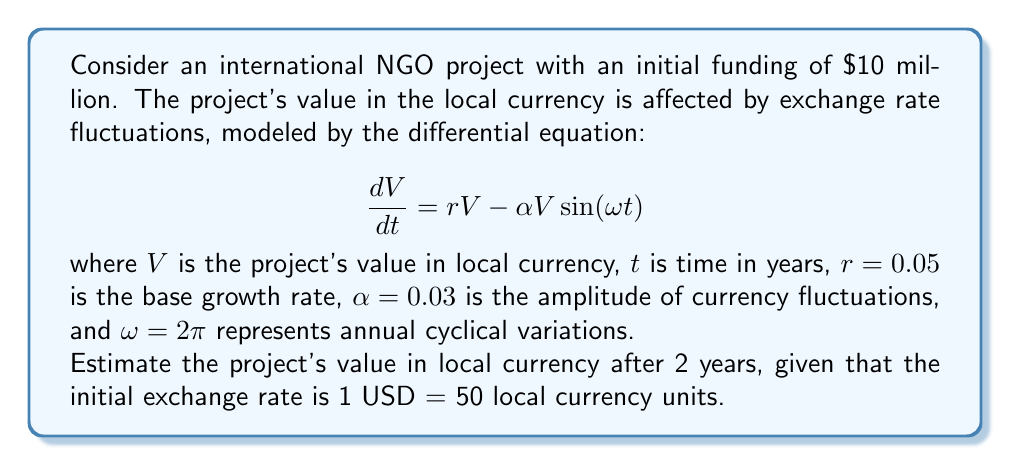Help me with this question. To solve this problem, we need to follow these steps:

1) First, we need to solve the given differential equation. This is a linear first-order differential equation with variable coefficients.

2) The general solution to this equation is:

   $$V(t) = C \exp\left(rt + \frac{\alpha}{\omega} \cos(\omega t)\right)$$

   where $C$ is a constant determined by the initial conditions.

3) At $t = 0$, we know that $V(0) = 10,000,000 * 50 = 500,000,000$ local currency units.

4) Substituting this into our general solution:

   $$500,000,000 = C \exp\left(0 + \frac{\alpha}{\omega} \cos(0)\right) = C \exp\left(\frac{\alpha}{\omega}\right)$$

5) Solving for $C$:

   $$C = 500,000,000 \exp\left(-\frac{\alpha}{\omega}\right)$$

6) Now we can write our particular solution:

   $$V(t) = 500,000,000 \exp\left(-\frac{\alpha}{\omega}\right) \exp\left(rt + \frac{\alpha}{\omega} \cos(\omega t)\right)$$

7) Simplifying:

   $$V(t) = 500,000,000 \exp\left(rt + \frac{\alpha}{\omega} (\cos(\omega t) - 1)\right)$$

8) Now we can evaluate this at $t = 2$:

   $$V(2) = 500,000,000 \exp\left(0.05*2 + \frac{0.03}{2\pi} (\cos(2\pi*2) - 1)\right)$$

9) Simplifying:

   $$V(2) = 500,000,000 \exp(0.1) = 500,000,000 * 1.1051709$$

10) Calculating the final result:

    $$V(2) = 552,585,450$$ local currency units
Answer: The estimated value of the project in local currency after 2 years is 552,585,450 local currency units. 